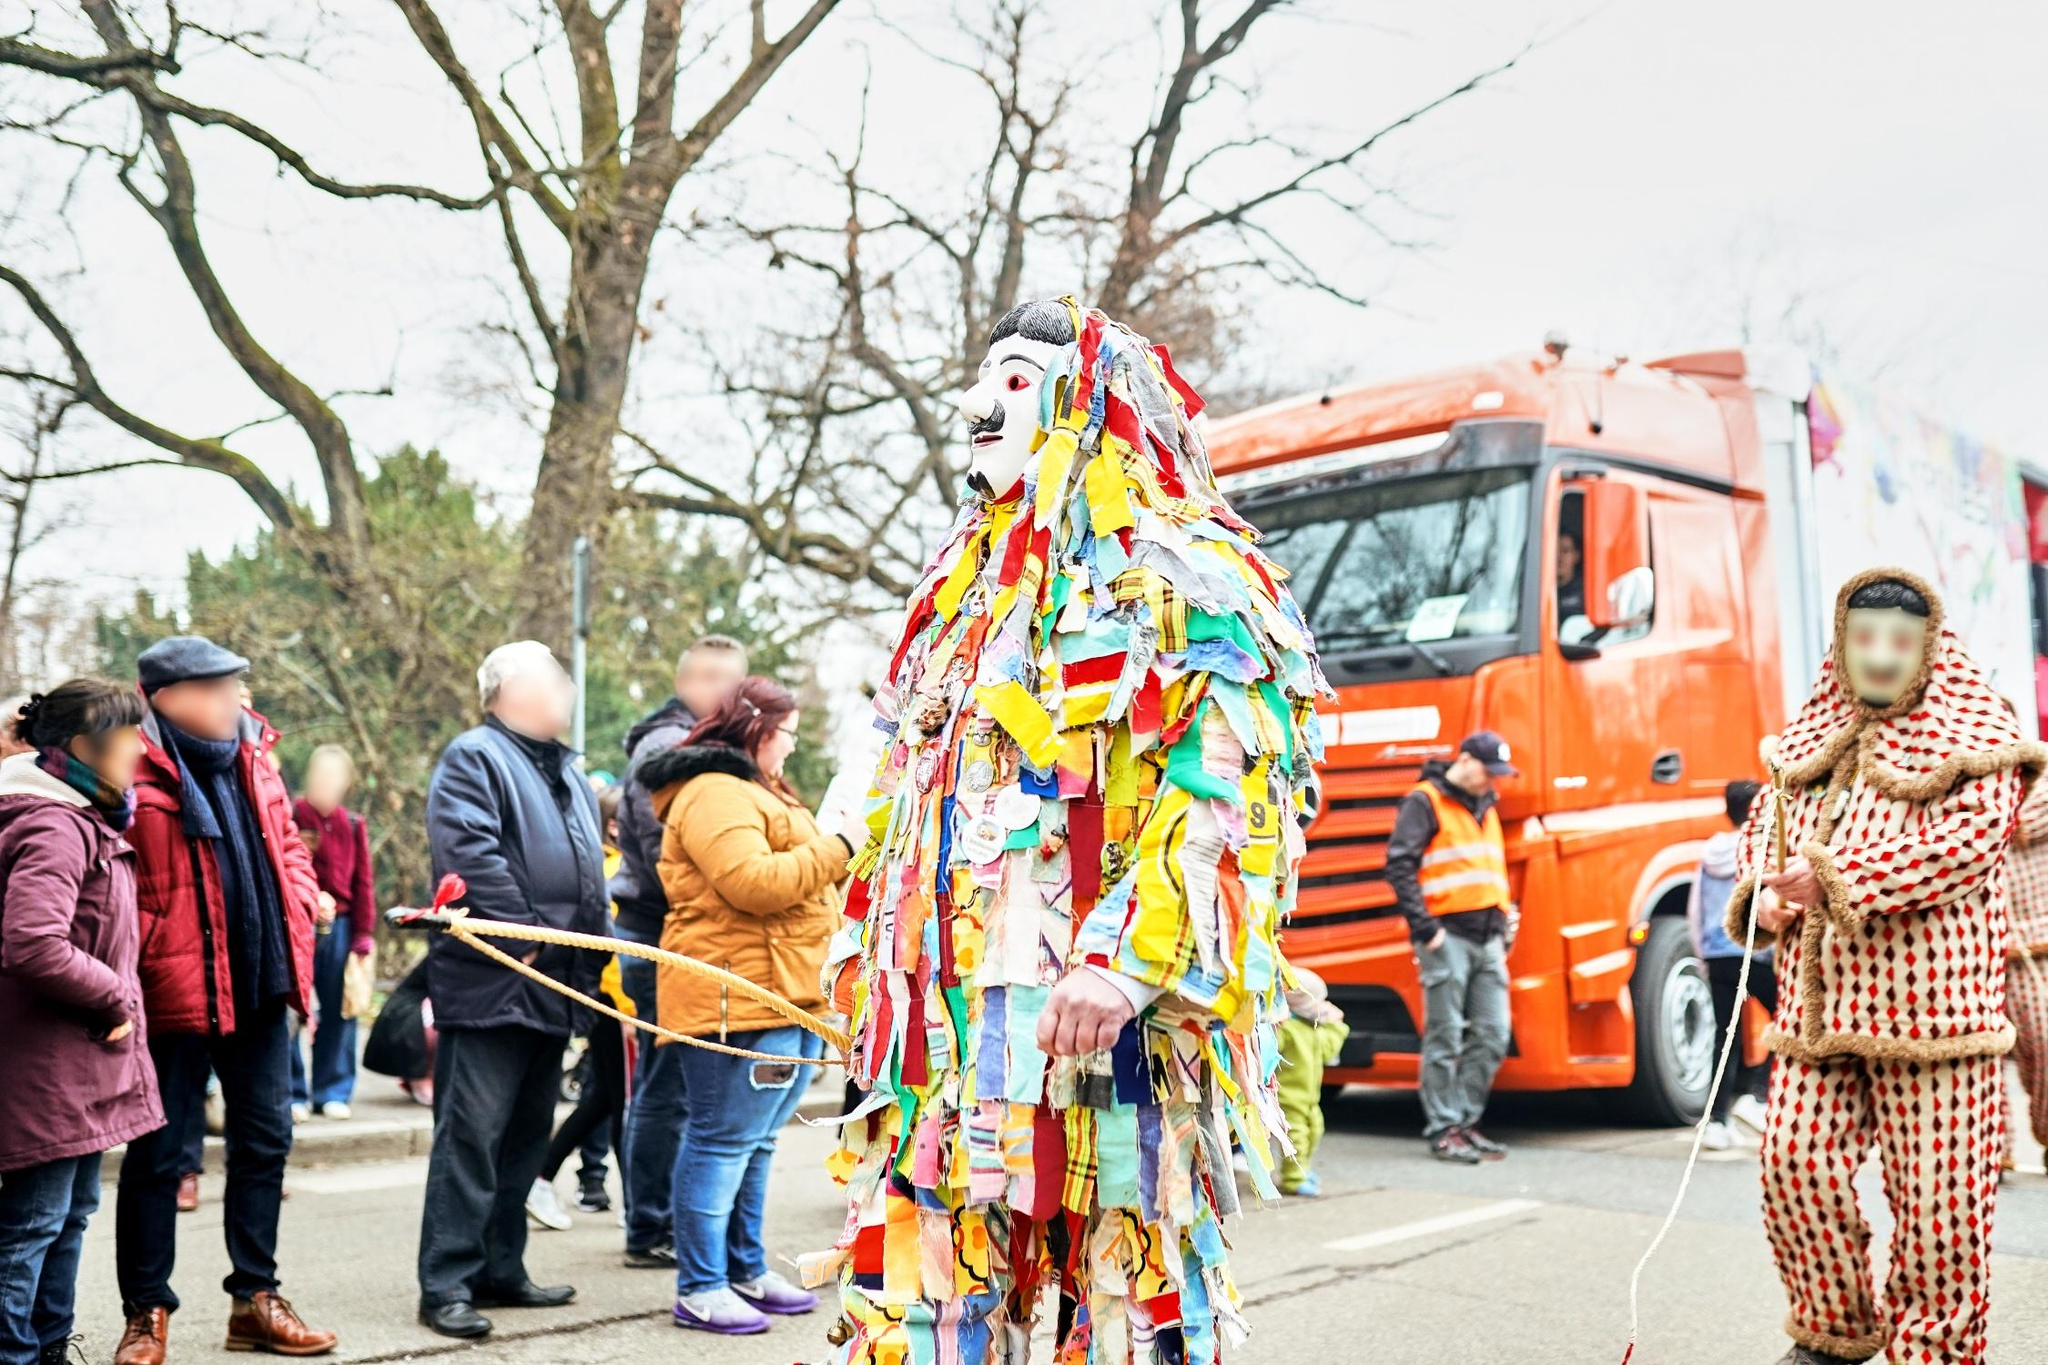Can you tell more about the design of the costume worn by the centerpiece character? Certainly! The costume worn by the central figure in the image is rich with vibrant multi-colored fabric strips that create a dynamic visual when in motion. Each strip appears to have been carefully placed to build up a layered, voluminous outfit that completely covers the individual. Notably, the materials and patterns represent a kaleidoscope of colors, possibly reflecting a wide range of cultural or artistic influences. The overall effect is both eye-catching and symbolically rich, potentially intended to invoke themes of celebration, diversity, or identity within the context of the parade. 